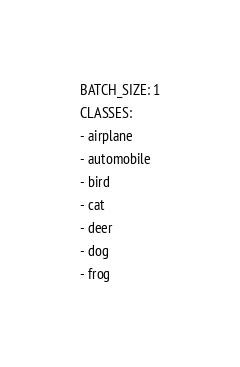Convert code to text. <code><loc_0><loc_0><loc_500><loc_500><_YAML_>BATCH_SIZE: 1
CLASSES:
- airplane
- automobile
- bird
- cat
- deer
- dog
- frog</code> 